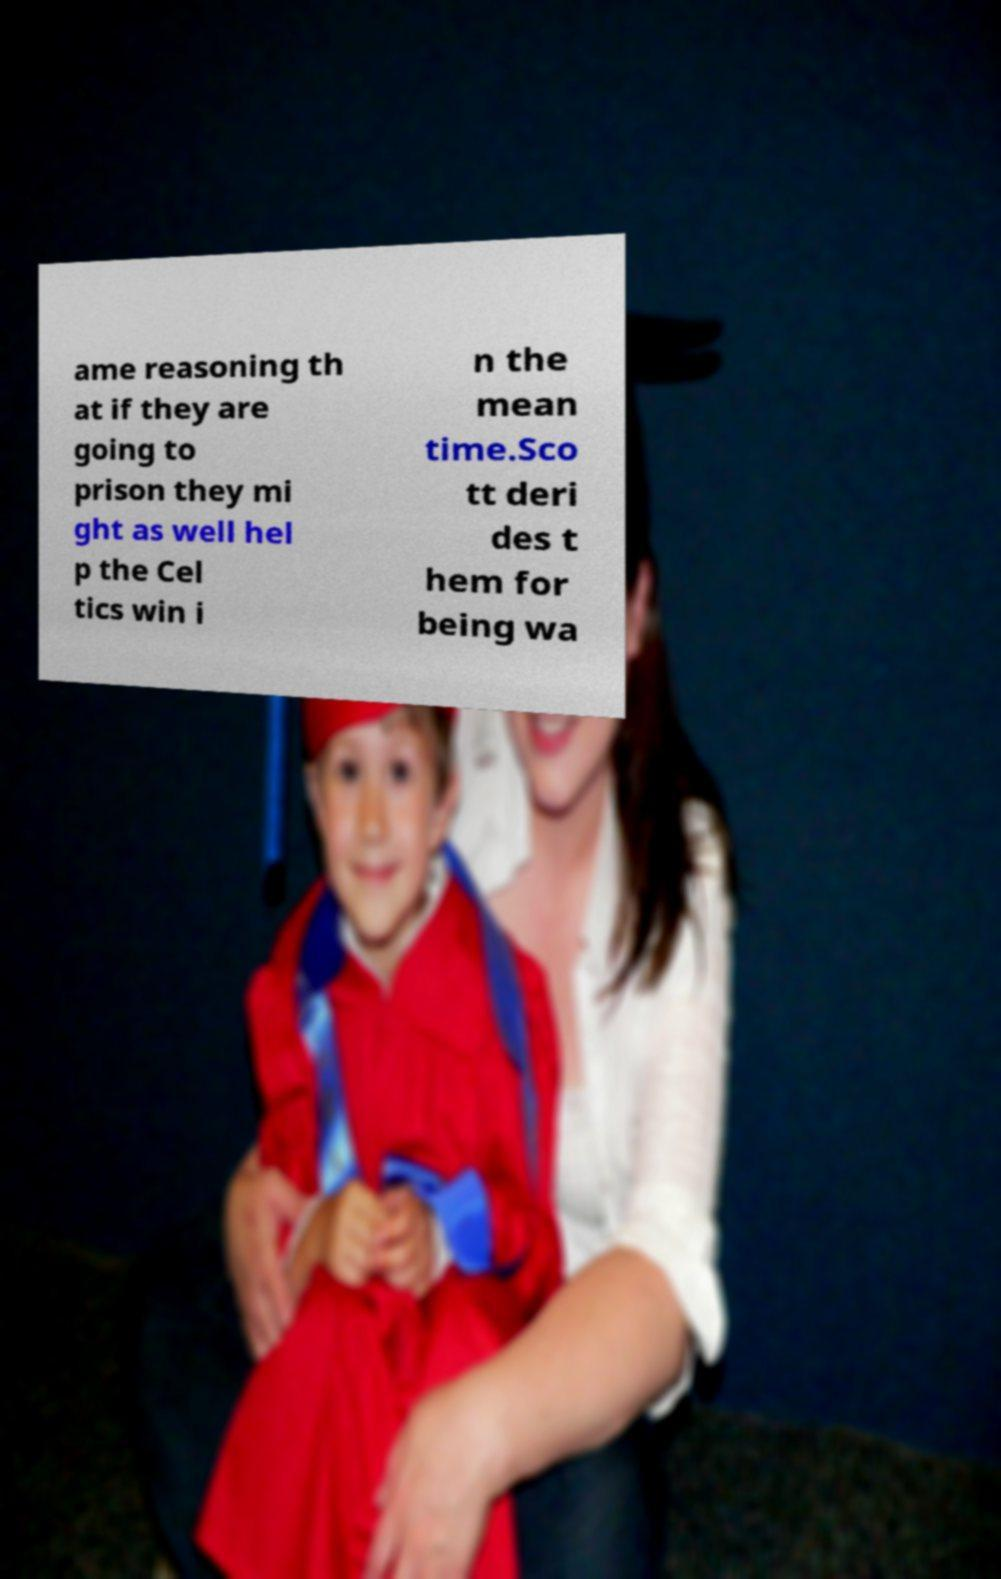I need the written content from this picture converted into text. Can you do that? ame reasoning th at if they are going to prison they mi ght as well hel p the Cel tics win i n the mean time.Sco tt deri des t hem for being wa 